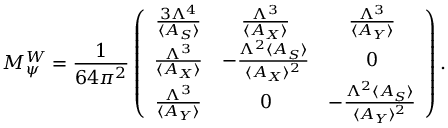Convert formula to latex. <formula><loc_0><loc_0><loc_500><loc_500>M _ { \psi } ^ { W } = { \frac { 1 } { 6 4 \pi ^ { 2 } } } \left ( \begin{array} { c c c } { { { \frac { 3 \Lambda ^ { 4 } } { \langle A _ { S } \rangle } } } } & { { { \frac { \Lambda ^ { 3 } } { \langle A _ { X } \rangle } } } } & { { { \frac { \Lambda ^ { 3 } } { \langle A _ { Y } \rangle } } } } \\ { { { \frac { \Lambda ^ { 3 } } { \langle A _ { X } \rangle } } } } & { { - { \frac { \Lambda ^ { 2 } \langle A _ { S } \rangle } { \langle A _ { X } \rangle ^ { 2 } } } } } & { 0 } \\ { { { \frac { \Lambda ^ { 3 } } { \langle A _ { Y } \rangle } } } } & { 0 } & { { - { \frac { \Lambda ^ { 2 } \langle A _ { S } \rangle } { \langle A _ { Y } \rangle ^ { 2 } } } } } \end{array} \right ) .</formula> 